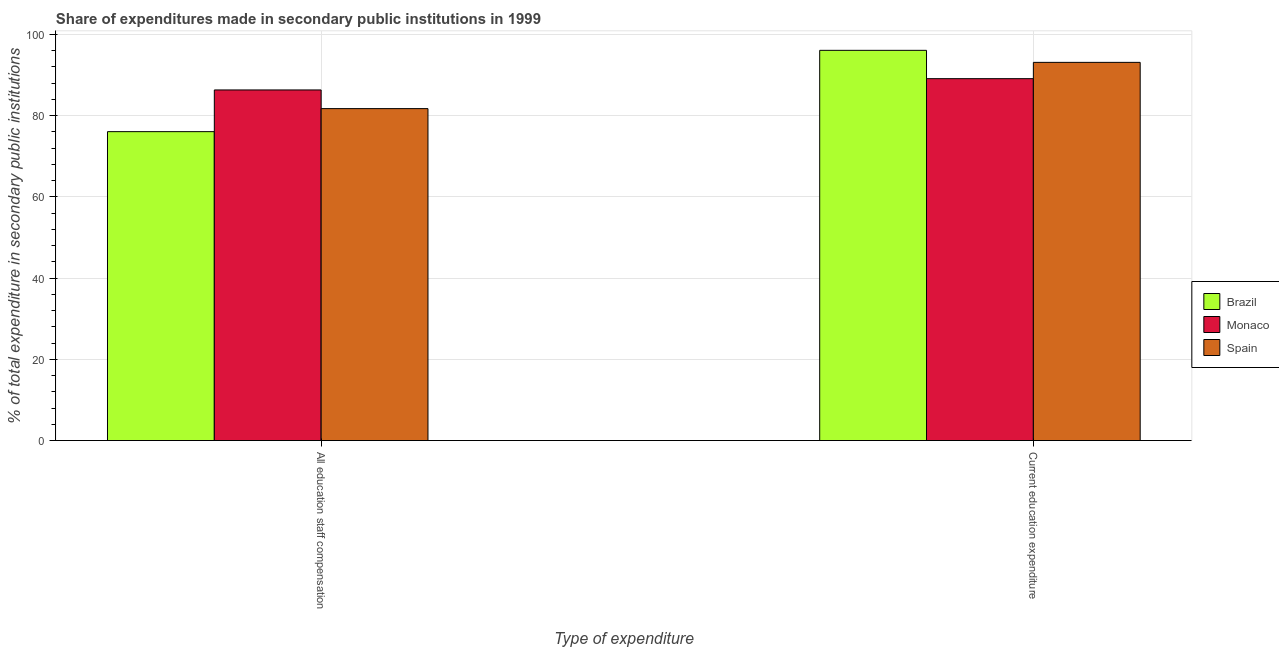How many groups of bars are there?
Make the answer very short. 2. Are the number of bars per tick equal to the number of legend labels?
Your answer should be compact. Yes. Are the number of bars on each tick of the X-axis equal?
Offer a terse response. Yes. How many bars are there on the 2nd tick from the left?
Provide a succinct answer. 3. How many bars are there on the 2nd tick from the right?
Make the answer very short. 3. What is the label of the 2nd group of bars from the left?
Keep it short and to the point. Current education expenditure. What is the expenditure in staff compensation in Monaco?
Offer a very short reply. 86.34. Across all countries, what is the maximum expenditure in education?
Offer a terse response. 96.09. Across all countries, what is the minimum expenditure in staff compensation?
Offer a terse response. 76.07. In which country was the expenditure in staff compensation maximum?
Offer a terse response. Monaco. What is the total expenditure in education in the graph?
Your response must be concise. 278.33. What is the difference between the expenditure in education in Monaco and that in Spain?
Keep it short and to the point. -4.01. What is the difference between the expenditure in education in Brazil and the expenditure in staff compensation in Spain?
Your response must be concise. 14.35. What is the average expenditure in education per country?
Your answer should be very brief. 92.78. What is the difference between the expenditure in staff compensation and expenditure in education in Monaco?
Give a very brief answer. -2.78. In how many countries, is the expenditure in staff compensation greater than 72 %?
Give a very brief answer. 3. What is the ratio of the expenditure in staff compensation in Brazil to that in Spain?
Ensure brevity in your answer.  0.93. Is the expenditure in staff compensation in Brazil less than that in Spain?
Provide a succinct answer. Yes. What does the 2nd bar from the right in All education staff compensation represents?
Your answer should be very brief. Monaco. Are all the bars in the graph horizontal?
Give a very brief answer. No. How many countries are there in the graph?
Give a very brief answer. 3. Are the values on the major ticks of Y-axis written in scientific E-notation?
Provide a succinct answer. No. Does the graph contain any zero values?
Give a very brief answer. No. What is the title of the graph?
Offer a terse response. Share of expenditures made in secondary public institutions in 1999. Does "Gabon" appear as one of the legend labels in the graph?
Ensure brevity in your answer.  No. What is the label or title of the X-axis?
Provide a succinct answer. Type of expenditure. What is the label or title of the Y-axis?
Give a very brief answer. % of total expenditure in secondary public institutions. What is the % of total expenditure in secondary public institutions in Brazil in All education staff compensation?
Ensure brevity in your answer.  76.07. What is the % of total expenditure in secondary public institutions of Monaco in All education staff compensation?
Your answer should be very brief. 86.34. What is the % of total expenditure in secondary public institutions in Spain in All education staff compensation?
Give a very brief answer. 81.74. What is the % of total expenditure in secondary public institutions of Brazil in Current education expenditure?
Your response must be concise. 96.09. What is the % of total expenditure in secondary public institutions of Monaco in Current education expenditure?
Make the answer very short. 89.11. What is the % of total expenditure in secondary public institutions of Spain in Current education expenditure?
Ensure brevity in your answer.  93.13. Across all Type of expenditure, what is the maximum % of total expenditure in secondary public institutions of Brazil?
Provide a short and direct response. 96.09. Across all Type of expenditure, what is the maximum % of total expenditure in secondary public institutions in Monaco?
Keep it short and to the point. 89.11. Across all Type of expenditure, what is the maximum % of total expenditure in secondary public institutions in Spain?
Ensure brevity in your answer.  93.13. Across all Type of expenditure, what is the minimum % of total expenditure in secondary public institutions in Brazil?
Ensure brevity in your answer.  76.07. Across all Type of expenditure, what is the minimum % of total expenditure in secondary public institutions of Monaco?
Keep it short and to the point. 86.34. Across all Type of expenditure, what is the minimum % of total expenditure in secondary public institutions of Spain?
Offer a terse response. 81.74. What is the total % of total expenditure in secondary public institutions in Brazil in the graph?
Your answer should be very brief. 172.16. What is the total % of total expenditure in secondary public institutions in Monaco in the graph?
Ensure brevity in your answer.  175.45. What is the total % of total expenditure in secondary public institutions of Spain in the graph?
Provide a short and direct response. 174.87. What is the difference between the % of total expenditure in secondary public institutions of Brazil in All education staff compensation and that in Current education expenditure?
Your response must be concise. -20.02. What is the difference between the % of total expenditure in secondary public institutions of Monaco in All education staff compensation and that in Current education expenditure?
Provide a succinct answer. -2.78. What is the difference between the % of total expenditure in secondary public institutions in Spain in All education staff compensation and that in Current education expenditure?
Your answer should be very brief. -11.39. What is the difference between the % of total expenditure in secondary public institutions in Brazil in All education staff compensation and the % of total expenditure in secondary public institutions in Monaco in Current education expenditure?
Provide a short and direct response. -13.05. What is the difference between the % of total expenditure in secondary public institutions of Brazil in All education staff compensation and the % of total expenditure in secondary public institutions of Spain in Current education expenditure?
Ensure brevity in your answer.  -17.06. What is the difference between the % of total expenditure in secondary public institutions of Monaco in All education staff compensation and the % of total expenditure in secondary public institutions of Spain in Current education expenditure?
Offer a terse response. -6.79. What is the average % of total expenditure in secondary public institutions of Brazil per Type of expenditure?
Your answer should be very brief. 86.08. What is the average % of total expenditure in secondary public institutions of Monaco per Type of expenditure?
Your response must be concise. 87.72. What is the average % of total expenditure in secondary public institutions in Spain per Type of expenditure?
Make the answer very short. 87.43. What is the difference between the % of total expenditure in secondary public institutions of Brazil and % of total expenditure in secondary public institutions of Monaco in All education staff compensation?
Offer a very short reply. -10.27. What is the difference between the % of total expenditure in secondary public institutions in Brazil and % of total expenditure in secondary public institutions in Spain in All education staff compensation?
Keep it short and to the point. -5.67. What is the difference between the % of total expenditure in secondary public institutions of Monaco and % of total expenditure in secondary public institutions of Spain in All education staff compensation?
Keep it short and to the point. 4.6. What is the difference between the % of total expenditure in secondary public institutions of Brazil and % of total expenditure in secondary public institutions of Monaco in Current education expenditure?
Provide a succinct answer. 6.98. What is the difference between the % of total expenditure in secondary public institutions of Brazil and % of total expenditure in secondary public institutions of Spain in Current education expenditure?
Make the answer very short. 2.96. What is the difference between the % of total expenditure in secondary public institutions in Monaco and % of total expenditure in secondary public institutions in Spain in Current education expenditure?
Make the answer very short. -4.01. What is the ratio of the % of total expenditure in secondary public institutions in Brazil in All education staff compensation to that in Current education expenditure?
Your answer should be compact. 0.79. What is the ratio of the % of total expenditure in secondary public institutions in Monaco in All education staff compensation to that in Current education expenditure?
Provide a short and direct response. 0.97. What is the ratio of the % of total expenditure in secondary public institutions in Spain in All education staff compensation to that in Current education expenditure?
Keep it short and to the point. 0.88. What is the difference between the highest and the second highest % of total expenditure in secondary public institutions in Brazil?
Offer a terse response. 20.02. What is the difference between the highest and the second highest % of total expenditure in secondary public institutions in Monaco?
Your response must be concise. 2.78. What is the difference between the highest and the second highest % of total expenditure in secondary public institutions in Spain?
Your response must be concise. 11.39. What is the difference between the highest and the lowest % of total expenditure in secondary public institutions of Brazil?
Your answer should be compact. 20.02. What is the difference between the highest and the lowest % of total expenditure in secondary public institutions in Monaco?
Offer a very short reply. 2.78. What is the difference between the highest and the lowest % of total expenditure in secondary public institutions of Spain?
Provide a short and direct response. 11.39. 